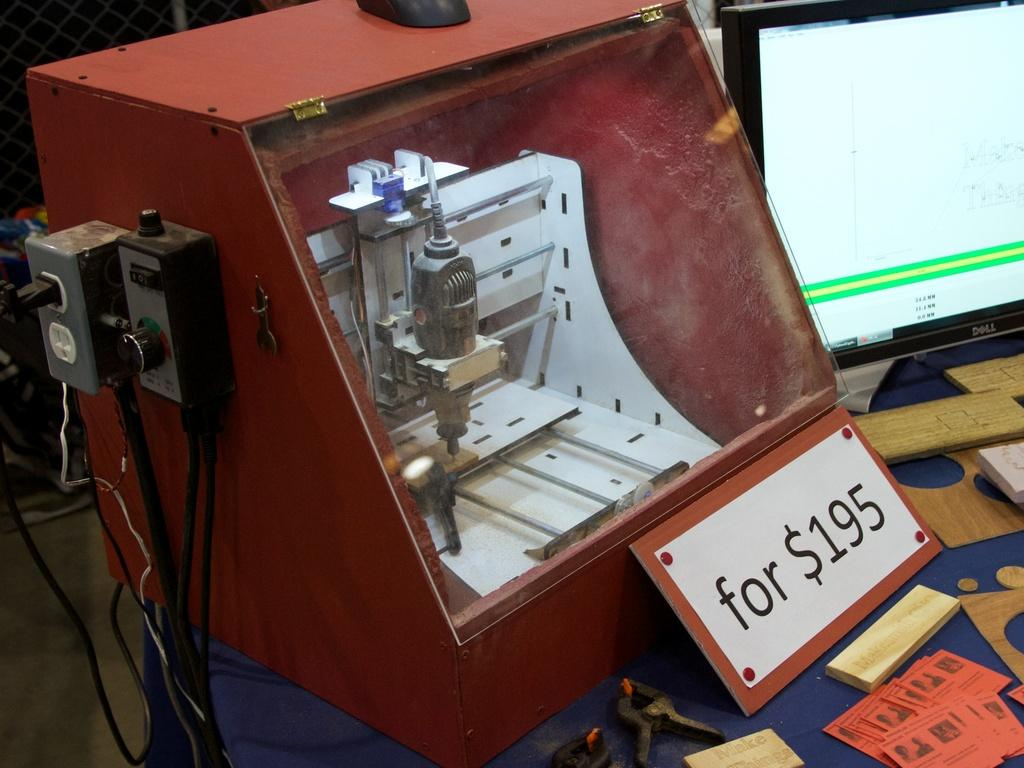<image>
Offer a succinct explanation of the picture presented. A machine sits inside of a red display box with a for sale sign of $195 in front of it 